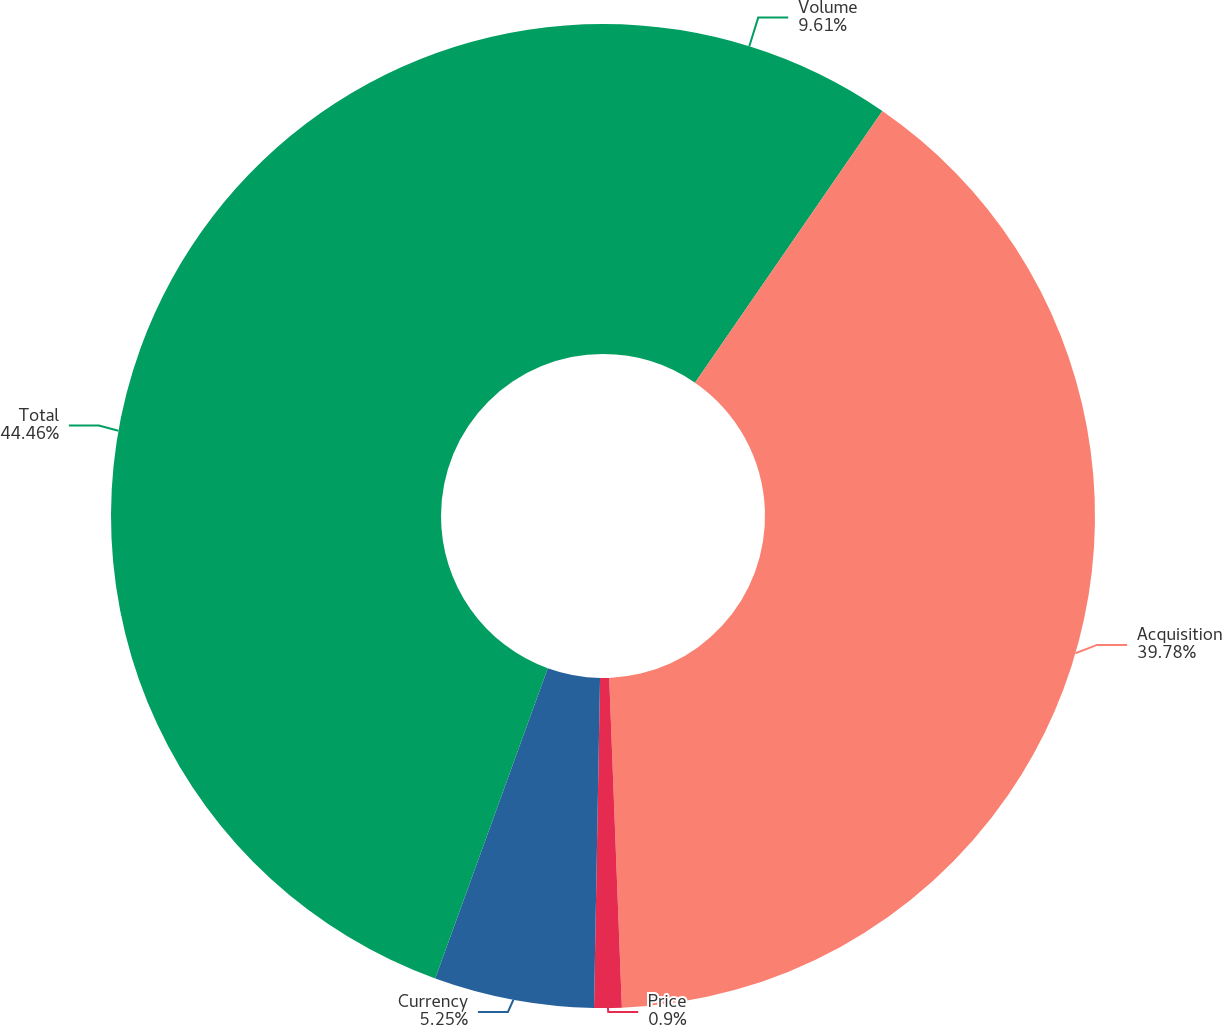Convert chart. <chart><loc_0><loc_0><loc_500><loc_500><pie_chart><fcel>Volume<fcel>Acquisition<fcel>Price<fcel>Currency<fcel>Total<nl><fcel>9.61%<fcel>39.78%<fcel>0.9%<fcel>5.25%<fcel>44.46%<nl></chart> 